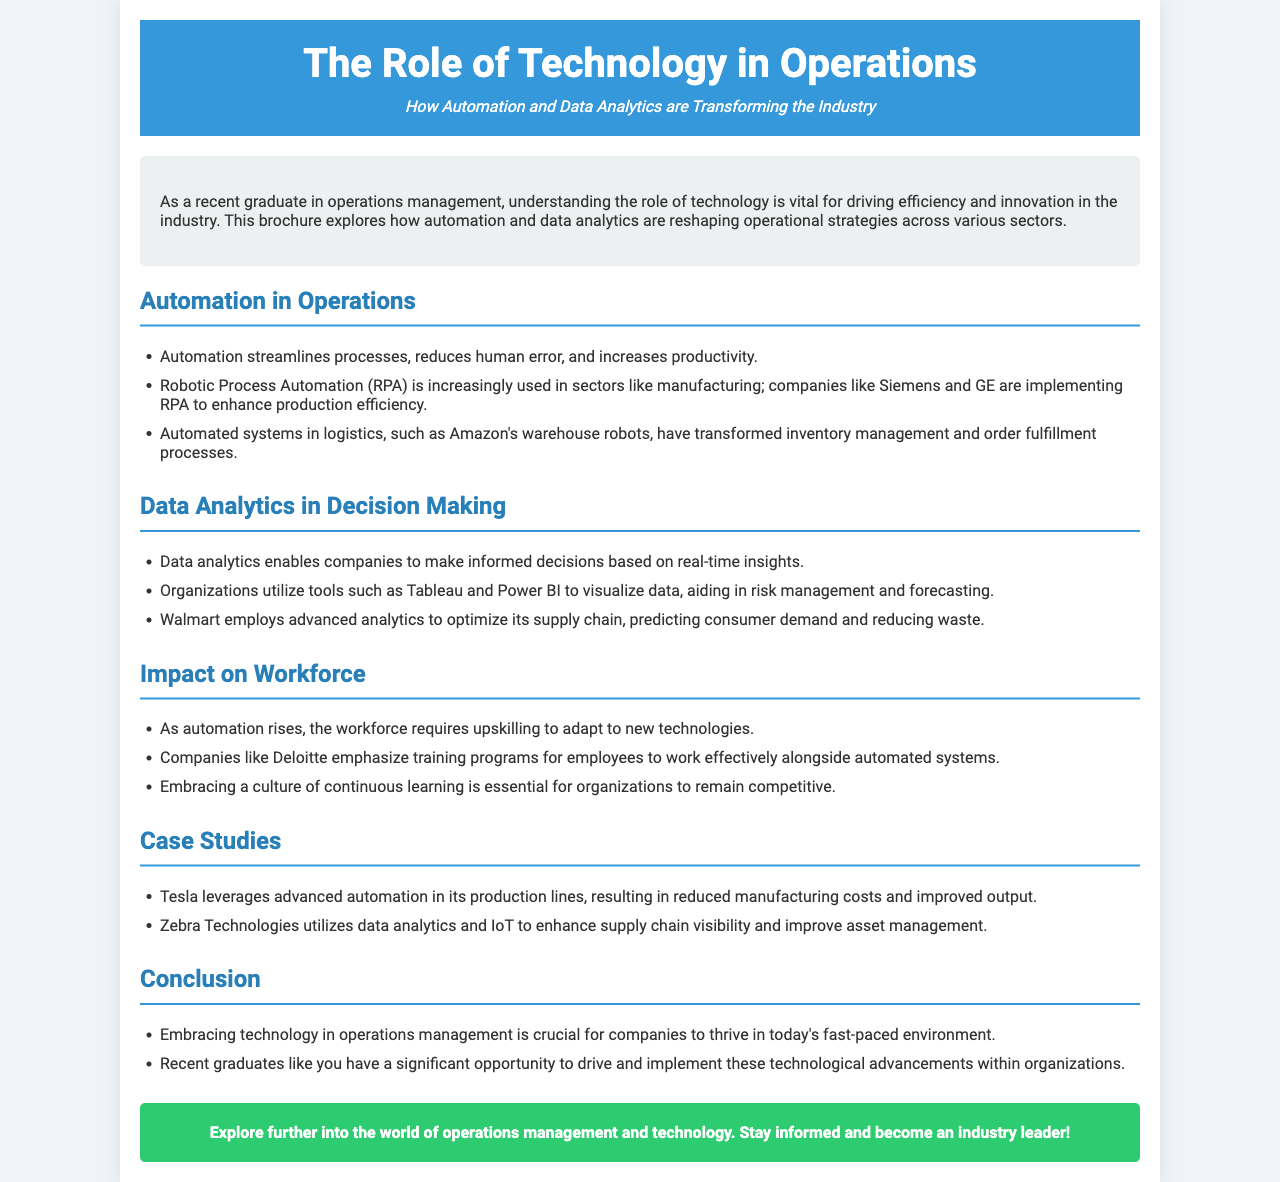What is the main focus of the brochure? The brochure focuses on how technology, specifically automation and data analytics, transforms operations management.
Answer: Technology in operations Which company is mentioned as using Robotic Process Automation? Siemens and GE are mentioned as companies implementing RPA in manufacturing.
Answer: Siemens and GE What tool is used for data visualization in organizations? The brochure mentions Tableau and Power BI as tools for visualizing data.
Answer: Tableau and Power BI What major retailer optimizes its supply chain using advanced analytics? Walmart is highlighted as employing advanced analytics for supply chain optimization.
Answer: Walmart What kind of culture do companies need to embrace to remain competitive? The document emphasizes the need for organizations to adopt a culture of continuous learning.
Answer: Continuous learning How does Tesla utilize technology according to the brochure? Tesla leverages advanced automation in production lines for improved output.
Answer: Advanced automation What is the impact of automation on the workforce? The workforce requires upskilling to adapt to new technologies due to rising automation.
Answer: Upskilling What is the call to action at the end of the brochure? The brochure encourages readers to explore further into operations management and technology.
Answer: Explore further 